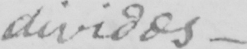Can you tell me what this handwritten text says? divides 